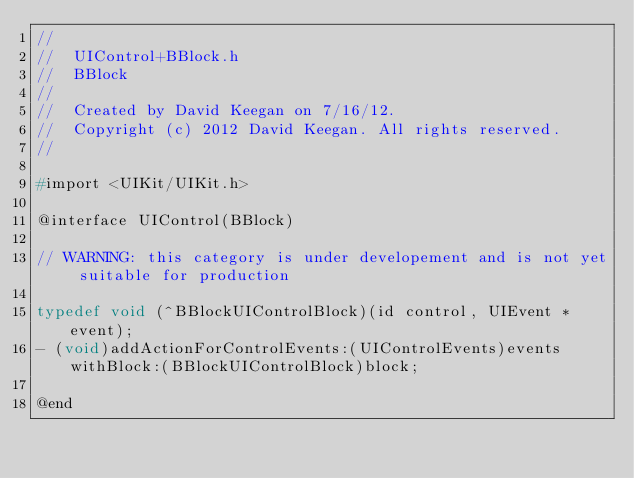Convert code to text. <code><loc_0><loc_0><loc_500><loc_500><_C_>//
//  UIControl+BBlock.h
//  BBlock
//
//  Created by David Keegan on 7/16/12.
//  Copyright (c) 2012 David Keegan. All rights reserved.
//

#import <UIKit/UIKit.h>

@interface UIControl(BBlock)

// WARNING: this category is under developement and is not yet suitable for production

typedef void (^BBlockUIControlBlock)(id control, UIEvent *event);
- (void)addActionForControlEvents:(UIControlEvents)events withBlock:(BBlockUIControlBlock)block;

@end
</code> 